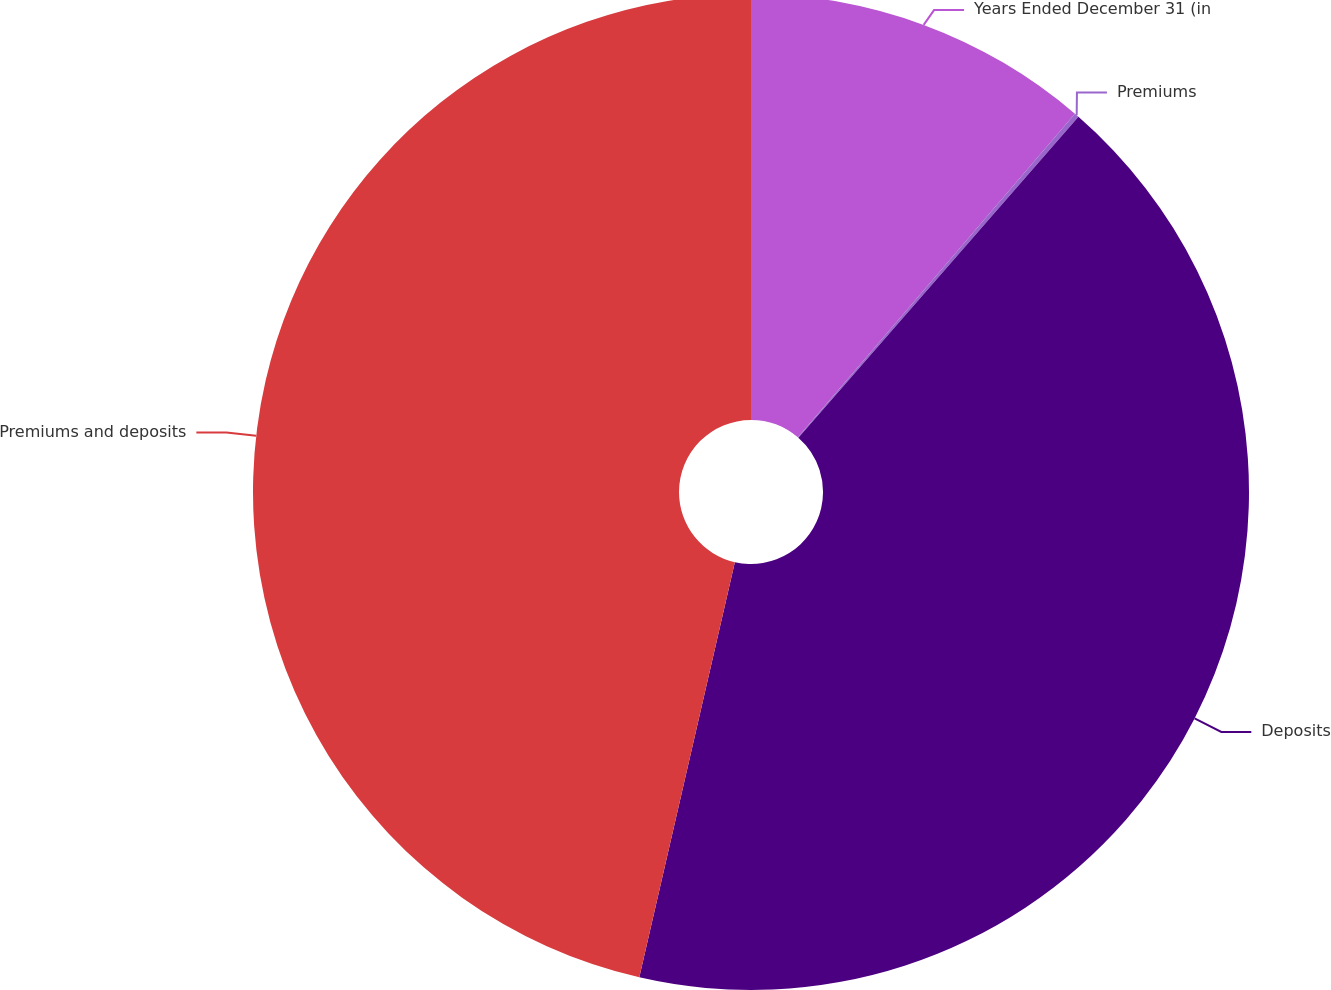Convert chart to OTSL. <chart><loc_0><loc_0><loc_500><loc_500><pie_chart><fcel>Years Ended December 31 (in<fcel>Premiums<fcel>Deposits<fcel>Premiums and deposits<nl><fcel>11.27%<fcel>0.15%<fcel>42.18%<fcel>46.4%<nl></chart> 